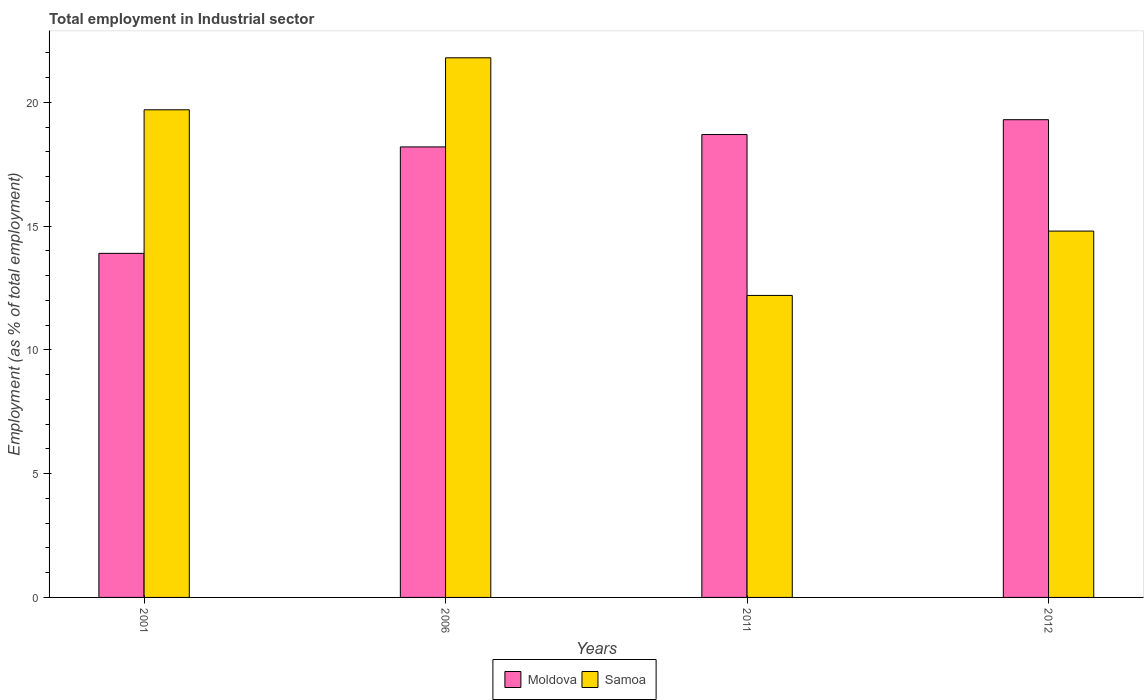How many different coloured bars are there?
Make the answer very short. 2. What is the employment in industrial sector in Moldova in 2001?
Your answer should be compact. 13.9. Across all years, what is the maximum employment in industrial sector in Moldova?
Your answer should be very brief. 19.3. Across all years, what is the minimum employment in industrial sector in Moldova?
Offer a terse response. 13.9. In which year was the employment in industrial sector in Samoa maximum?
Offer a very short reply. 2006. What is the total employment in industrial sector in Samoa in the graph?
Give a very brief answer. 68.5. What is the difference between the employment in industrial sector in Moldova in 2001 and the employment in industrial sector in Samoa in 2012?
Offer a terse response. -0.9. What is the average employment in industrial sector in Samoa per year?
Ensure brevity in your answer.  17.12. In the year 2012, what is the difference between the employment in industrial sector in Samoa and employment in industrial sector in Moldova?
Offer a terse response. -4.5. What is the ratio of the employment in industrial sector in Moldova in 2001 to that in 2011?
Provide a short and direct response. 0.74. Is the difference between the employment in industrial sector in Samoa in 2011 and 2012 greater than the difference between the employment in industrial sector in Moldova in 2011 and 2012?
Your answer should be compact. No. What is the difference between the highest and the second highest employment in industrial sector in Moldova?
Give a very brief answer. 0.6. What is the difference between the highest and the lowest employment in industrial sector in Samoa?
Ensure brevity in your answer.  9.6. In how many years, is the employment in industrial sector in Moldova greater than the average employment in industrial sector in Moldova taken over all years?
Make the answer very short. 3. What does the 2nd bar from the left in 2006 represents?
Your response must be concise. Samoa. What does the 1st bar from the right in 2012 represents?
Your answer should be compact. Samoa. How many years are there in the graph?
Your answer should be compact. 4. What is the difference between two consecutive major ticks on the Y-axis?
Keep it short and to the point. 5. Are the values on the major ticks of Y-axis written in scientific E-notation?
Provide a short and direct response. No. Does the graph contain any zero values?
Offer a terse response. No. Does the graph contain grids?
Ensure brevity in your answer.  No. How are the legend labels stacked?
Make the answer very short. Horizontal. What is the title of the graph?
Keep it short and to the point. Total employment in Industrial sector. What is the label or title of the X-axis?
Your answer should be very brief. Years. What is the label or title of the Y-axis?
Offer a terse response. Employment (as % of total employment). What is the Employment (as % of total employment) in Moldova in 2001?
Ensure brevity in your answer.  13.9. What is the Employment (as % of total employment) in Samoa in 2001?
Your response must be concise. 19.7. What is the Employment (as % of total employment) in Moldova in 2006?
Give a very brief answer. 18.2. What is the Employment (as % of total employment) of Samoa in 2006?
Keep it short and to the point. 21.8. What is the Employment (as % of total employment) of Moldova in 2011?
Your answer should be very brief. 18.7. What is the Employment (as % of total employment) of Samoa in 2011?
Your response must be concise. 12.2. What is the Employment (as % of total employment) of Moldova in 2012?
Give a very brief answer. 19.3. What is the Employment (as % of total employment) in Samoa in 2012?
Your response must be concise. 14.8. Across all years, what is the maximum Employment (as % of total employment) in Moldova?
Give a very brief answer. 19.3. Across all years, what is the maximum Employment (as % of total employment) of Samoa?
Give a very brief answer. 21.8. Across all years, what is the minimum Employment (as % of total employment) in Moldova?
Your answer should be compact. 13.9. Across all years, what is the minimum Employment (as % of total employment) in Samoa?
Your answer should be compact. 12.2. What is the total Employment (as % of total employment) of Moldova in the graph?
Ensure brevity in your answer.  70.1. What is the total Employment (as % of total employment) in Samoa in the graph?
Your answer should be compact. 68.5. What is the difference between the Employment (as % of total employment) in Samoa in 2001 and that in 2006?
Make the answer very short. -2.1. What is the difference between the Employment (as % of total employment) of Samoa in 2001 and that in 2011?
Your answer should be compact. 7.5. What is the difference between the Employment (as % of total employment) in Moldova in 2006 and that in 2011?
Ensure brevity in your answer.  -0.5. What is the difference between the Employment (as % of total employment) in Samoa in 2006 and that in 2012?
Offer a terse response. 7. What is the difference between the Employment (as % of total employment) in Samoa in 2011 and that in 2012?
Offer a very short reply. -2.6. What is the difference between the Employment (as % of total employment) of Moldova in 2001 and the Employment (as % of total employment) of Samoa in 2011?
Your response must be concise. 1.7. What is the average Employment (as % of total employment) in Moldova per year?
Provide a short and direct response. 17.52. What is the average Employment (as % of total employment) in Samoa per year?
Keep it short and to the point. 17.12. In the year 2001, what is the difference between the Employment (as % of total employment) of Moldova and Employment (as % of total employment) of Samoa?
Offer a very short reply. -5.8. In the year 2012, what is the difference between the Employment (as % of total employment) of Moldova and Employment (as % of total employment) of Samoa?
Offer a very short reply. 4.5. What is the ratio of the Employment (as % of total employment) of Moldova in 2001 to that in 2006?
Offer a very short reply. 0.76. What is the ratio of the Employment (as % of total employment) in Samoa in 2001 to that in 2006?
Ensure brevity in your answer.  0.9. What is the ratio of the Employment (as % of total employment) of Moldova in 2001 to that in 2011?
Offer a very short reply. 0.74. What is the ratio of the Employment (as % of total employment) of Samoa in 2001 to that in 2011?
Provide a succinct answer. 1.61. What is the ratio of the Employment (as % of total employment) in Moldova in 2001 to that in 2012?
Your response must be concise. 0.72. What is the ratio of the Employment (as % of total employment) in Samoa in 2001 to that in 2012?
Offer a very short reply. 1.33. What is the ratio of the Employment (as % of total employment) in Moldova in 2006 to that in 2011?
Make the answer very short. 0.97. What is the ratio of the Employment (as % of total employment) of Samoa in 2006 to that in 2011?
Offer a very short reply. 1.79. What is the ratio of the Employment (as % of total employment) in Moldova in 2006 to that in 2012?
Keep it short and to the point. 0.94. What is the ratio of the Employment (as % of total employment) of Samoa in 2006 to that in 2012?
Offer a terse response. 1.47. What is the ratio of the Employment (as % of total employment) of Moldova in 2011 to that in 2012?
Keep it short and to the point. 0.97. What is the ratio of the Employment (as % of total employment) in Samoa in 2011 to that in 2012?
Offer a terse response. 0.82. What is the difference between the highest and the second highest Employment (as % of total employment) in Moldova?
Give a very brief answer. 0.6. What is the difference between the highest and the second highest Employment (as % of total employment) of Samoa?
Provide a succinct answer. 2.1. What is the difference between the highest and the lowest Employment (as % of total employment) of Samoa?
Provide a succinct answer. 9.6. 